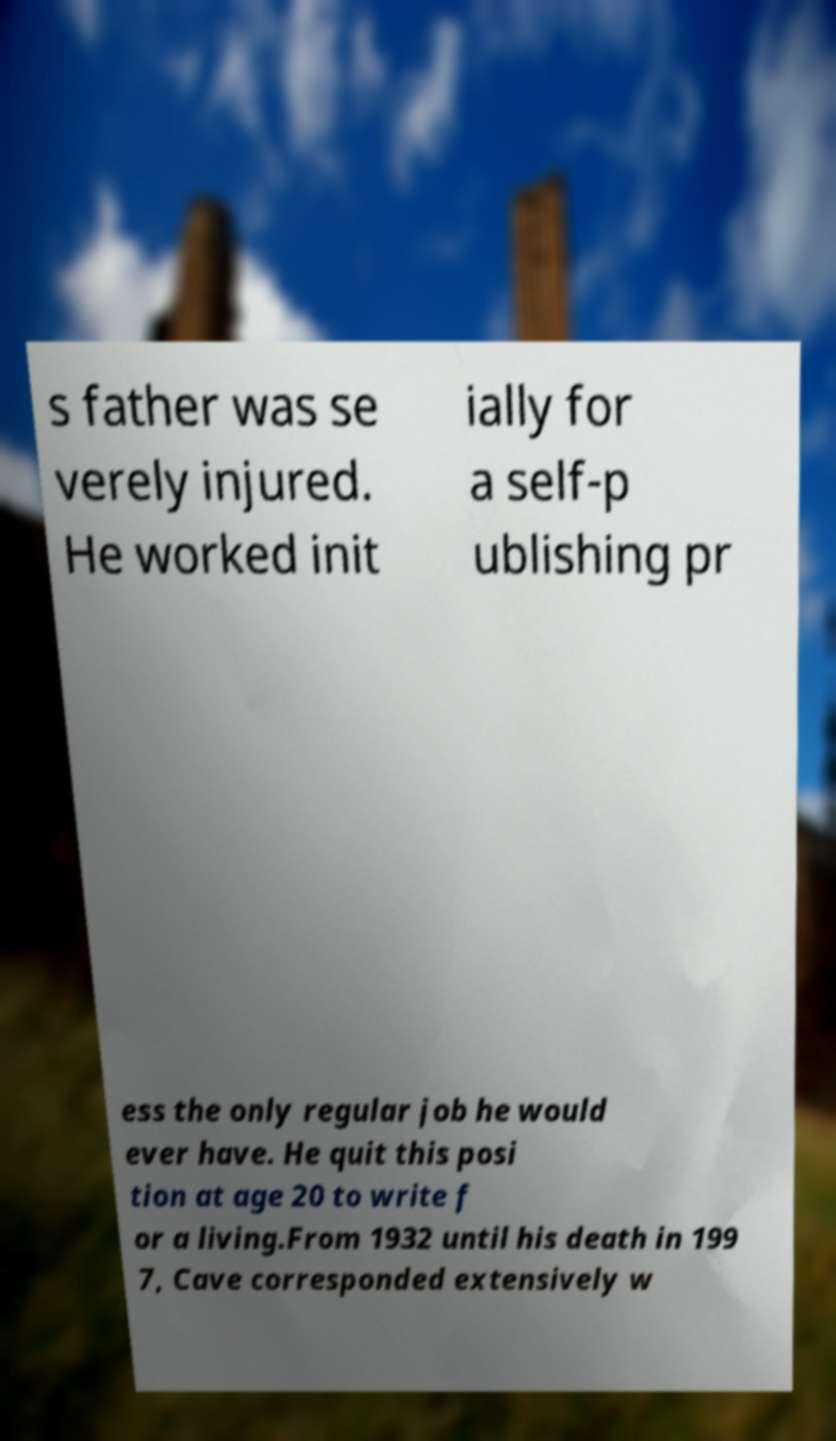Can you read and provide the text displayed in the image?This photo seems to have some interesting text. Can you extract and type it out for me? s father was se verely injured. He worked init ially for a self-p ublishing pr ess the only regular job he would ever have. He quit this posi tion at age 20 to write f or a living.From 1932 until his death in 199 7, Cave corresponded extensively w 